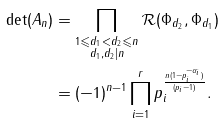<formula> <loc_0><loc_0><loc_500><loc_500>\det ( A _ { n } ) & = \prod _ { \substack { 1 \leqslant d _ { 1 } < d _ { 2 } \leqslant n \\ d _ { 1 } , d _ { 2 } | n } } \mathcal { R } ( \Phi _ { d _ { 2 } } , \Phi _ { d _ { 1 } } ) \\ & = ( - 1 ) ^ { n - 1 } \prod _ { i = 1 } ^ { r } p _ { i } ^ { \frac { n ( 1 - p _ { i } ^ { - \alpha _ { i } } ) } { ( p _ { i } - 1 ) } } .</formula> 